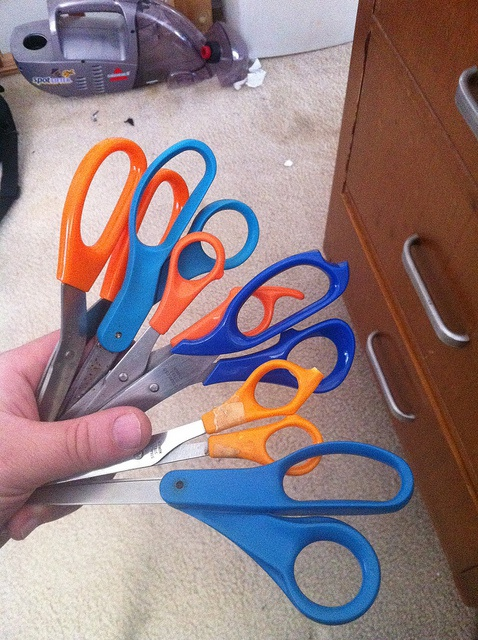Describe the objects in this image and their specific colors. I can see scissors in darkgray, blue, and gray tones, scissors in darkgray, blue, gray, and lightgray tones, scissors in darkgray, darkblue, gray, and blue tones, people in darkgray, lightpink, brown, and salmon tones, and scissors in darkgray, red, lightgray, gray, and orange tones in this image. 